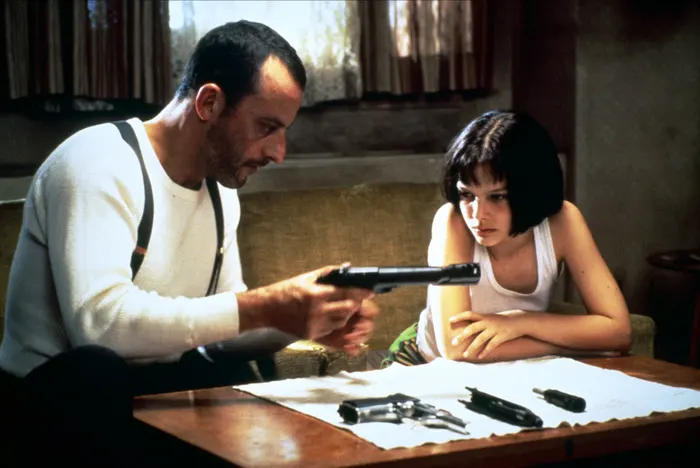Explain the visual content of the image in great detail. In the image, we are presented with a pivotal scene from the film "Léon: The Professional." The focus is on two central characters: Léon, portrayed by Jean Reno, and Mathilda, played by Natalie Portman. Both characters are intently engaged in what appears to be a tense moment. They are seated at a wooden table adorned with an array of firearms. Léon, dressed in a white tank top with black suspenders, meticulously handles a handgun, his concentration evident in his demeanor. Adjacent to him, Mathilda, who is also clad in a white tank top, looks on with a mixture of concern and curiosity. Her short, dark hair and black choker necklace add to her youthful yet hardened appearance. The room they occupy has a somber ambiance, accentuated by a beige wall, a curtained window, and a small green plant that offers a touch of life to the otherwise stark setting. 